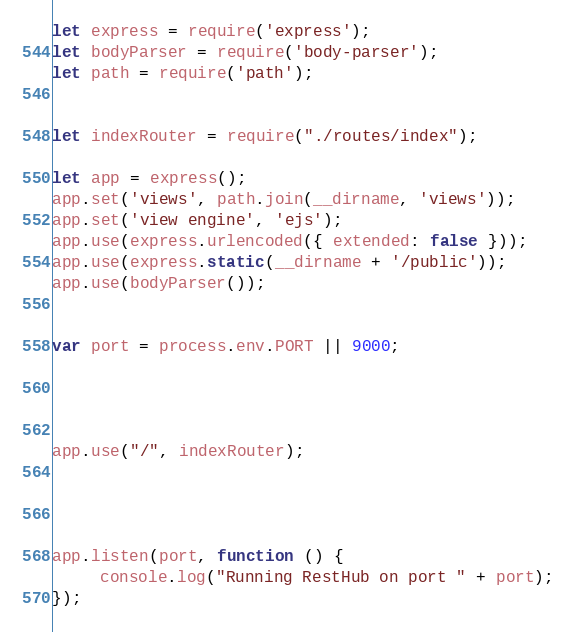Convert code to text. <code><loc_0><loc_0><loc_500><loc_500><_JavaScript_>let express = require('express');
let bodyParser = require('body-parser');
let path = require('path');


let indexRouter = require("./routes/index");

let app = express();
app.set('views', path.join(__dirname, 'views'));
app.set('view engine', 'ejs');
app.use(express.urlencoded({ extended: false }));
app.use(express.static(__dirname + '/public'));
app.use(bodyParser());


var port = process.env.PORT || 9000;




app.use("/", indexRouter);




app.listen(port, function () {
     console.log("Running RestHub on port " + port);
});
</code> 